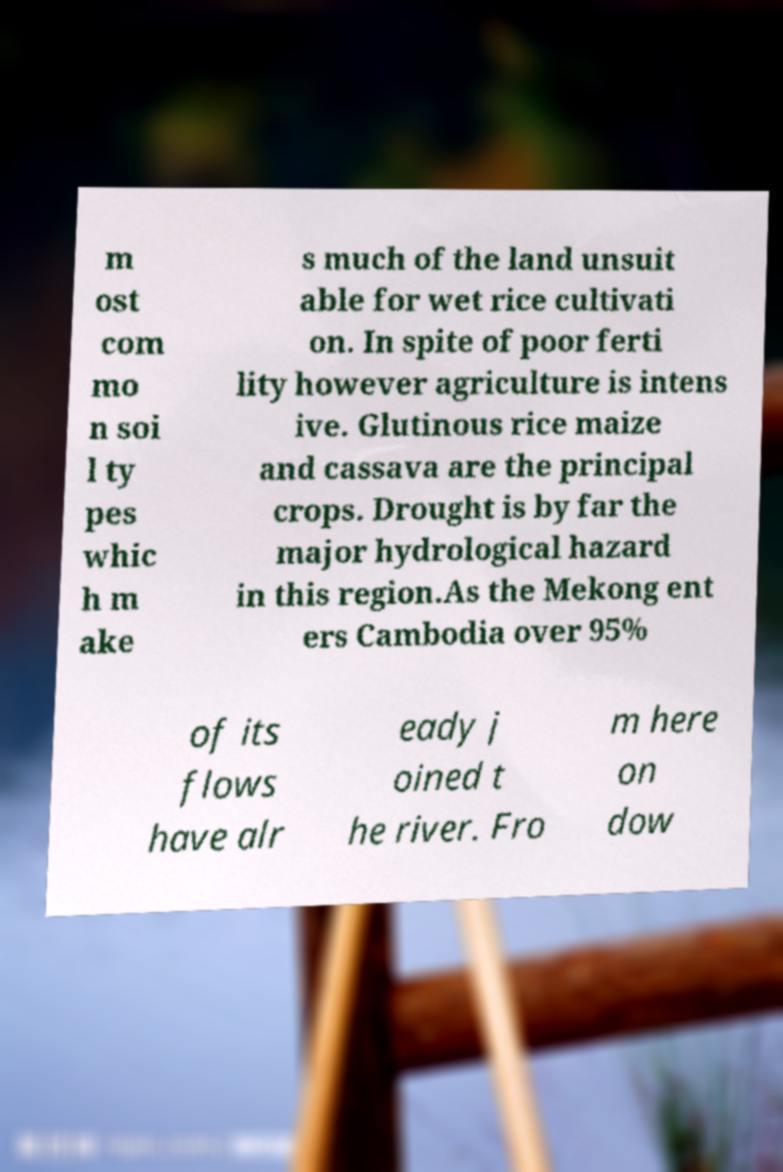Please read and relay the text visible in this image. What does it say? m ost com mo n soi l ty pes whic h m ake s much of the land unsuit able for wet rice cultivati on. In spite of poor ferti lity however agriculture is intens ive. Glutinous rice maize and cassava are the principal crops. Drought is by far the major hydrological hazard in this region.As the Mekong ent ers Cambodia over 95% of its flows have alr eady j oined t he river. Fro m here on dow 